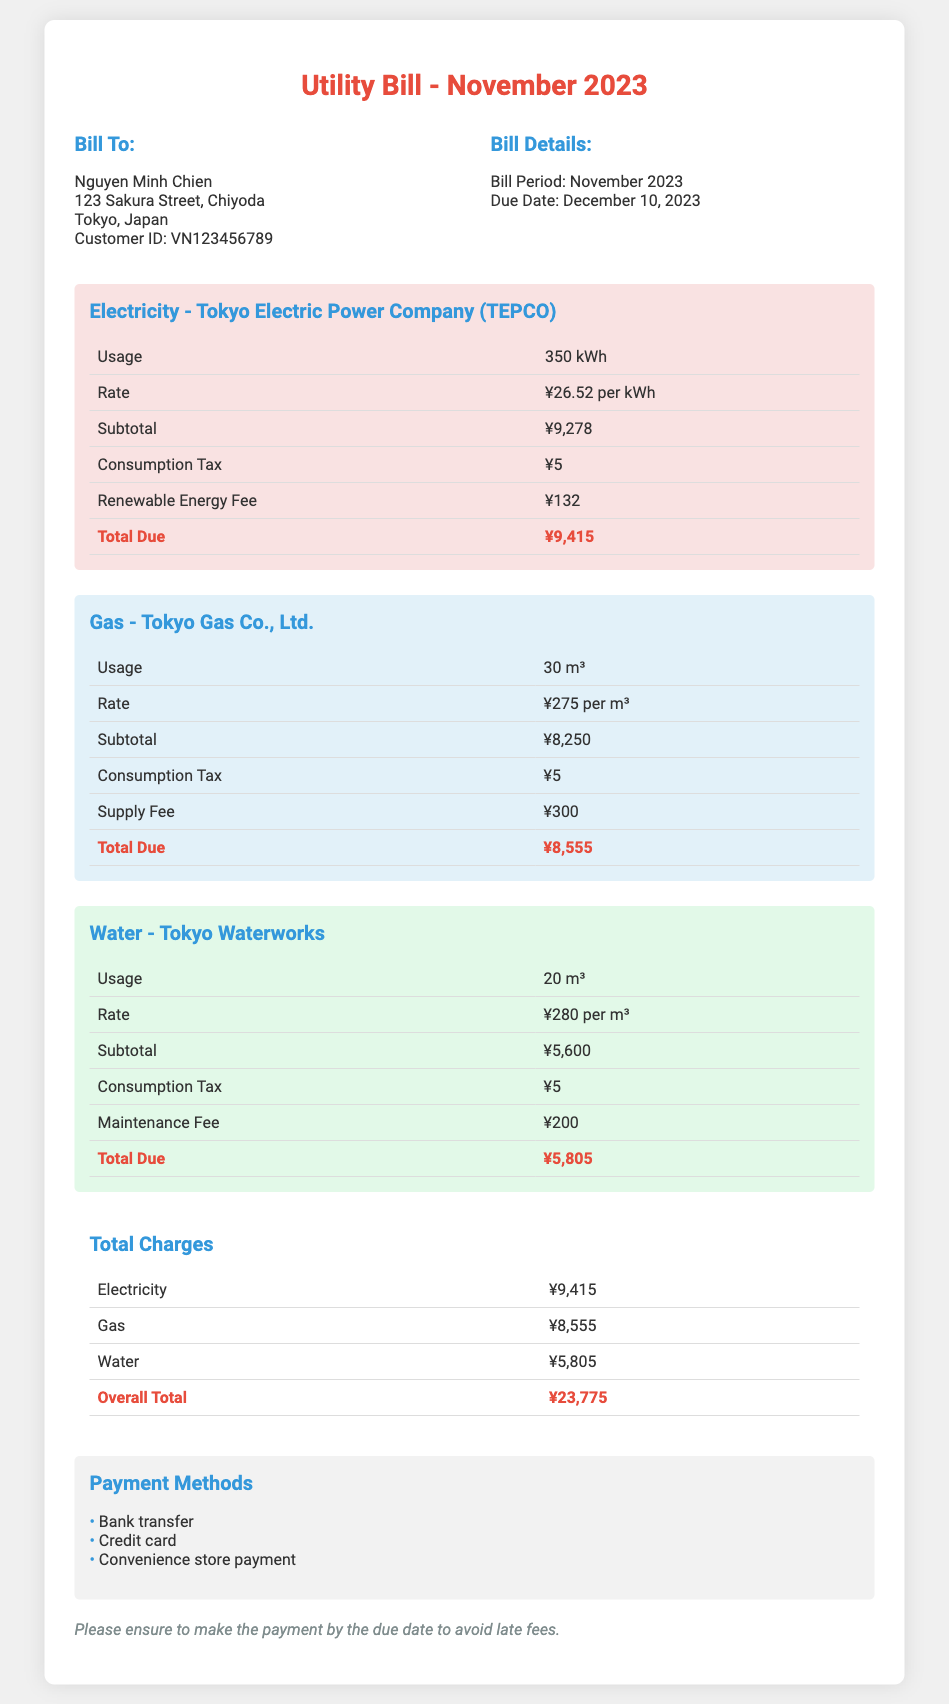What is the total amount due for electricity? The total amount due for electricity is listed at the end of the electricity section in the document.
Answer: ¥9,415 What is the gas usage in November 2023? The gas usage is explicitly stated in the gas section of the document.
Answer: 30 m³ What is the customer ID for Nguyen Minh Chien? The customer ID is provided in the bill information section for Nguyen Minh Chien.
Answer: VN123456789 What is the due date for the utility bill? The due date is mentioned in the bill details section of the document.
Answer: December 10, 2023 What is the overall total amount due for the utility bill? The overall total amount is calculated by adding all service totals together at the end of the bill.
Answer: ¥23,775 What is the maintenance fee for water? The maintenance fee is specified in the water section of the document.
Answer: ¥200 How much is the consumption tax for gas? The consumption tax for gas is provided in the gas section of the document.
Answer: ¥5 What payment methods are available? The payment methods are listed in the payment information section.
Answer: Bank transfer, Credit card, Convenience store payment What is the rate per cubic meter for gas? The rate for gas per cubic meter is given in the gas section of the document.
Answer: ¥275 per m³ 